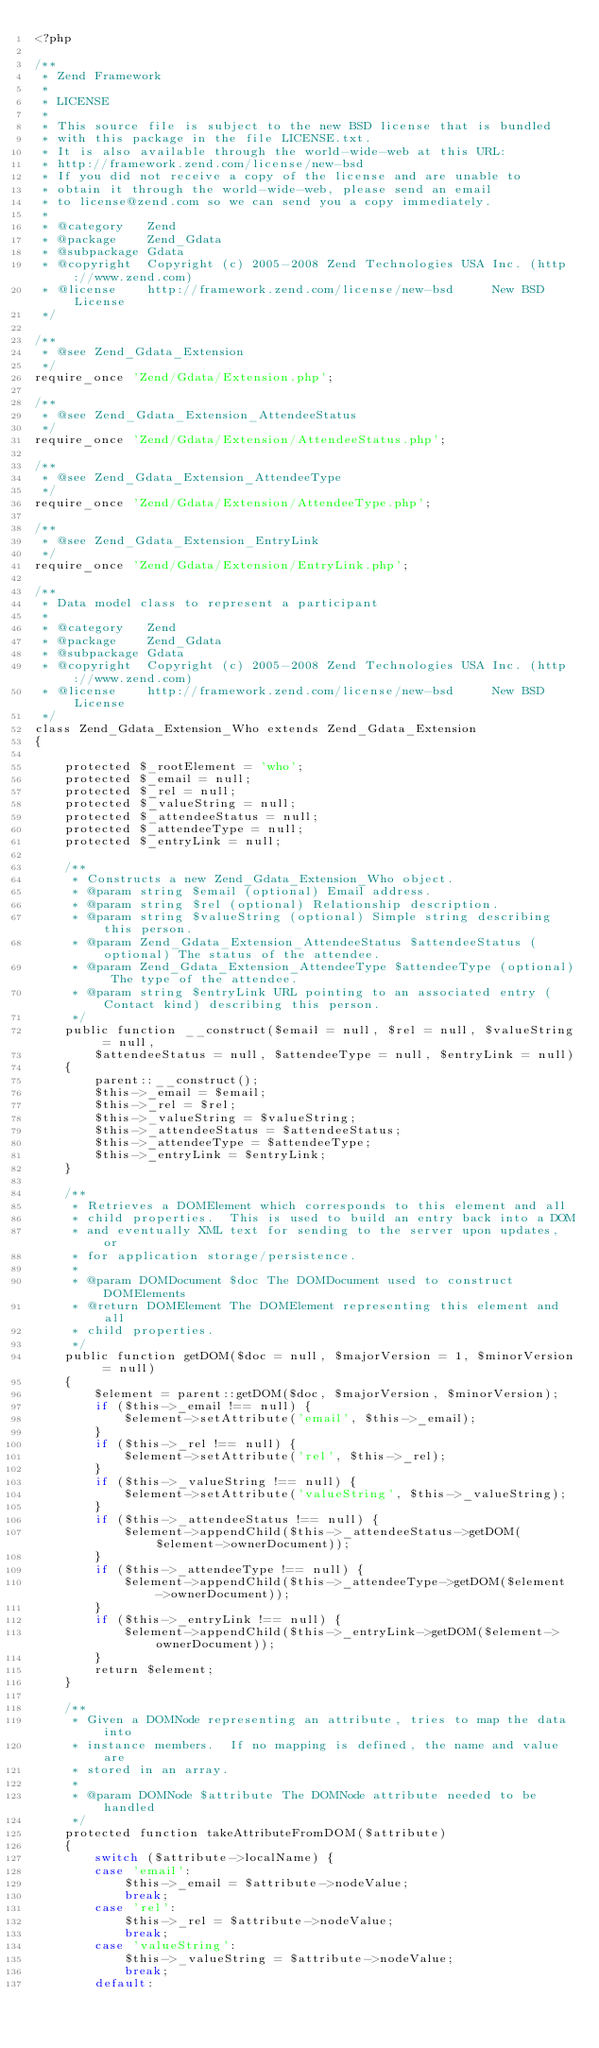Convert code to text. <code><loc_0><loc_0><loc_500><loc_500><_PHP_><?php

/**
 * Zend Framework
 *
 * LICENSE
 *
 * This source file is subject to the new BSD license that is bundled
 * with this package in the file LICENSE.txt.
 * It is also available through the world-wide-web at this URL:
 * http://framework.zend.com/license/new-bsd
 * If you did not receive a copy of the license and are unable to
 * obtain it through the world-wide-web, please send an email
 * to license@zend.com so we can send you a copy immediately.
 *
 * @category   Zend
 * @package    Zend_Gdata
 * @subpackage Gdata
 * @copyright  Copyright (c) 2005-2008 Zend Technologies USA Inc. (http://www.zend.com)
 * @license    http://framework.zend.com/license/new-bsd     New BSD License
 */

/**
 * @see Zend_Gdata_Extension
 */
require_once 'Zend/Gdata/Extension.php';

/**
 * @see Zend_Gdata_Extension_AttendeeStatus
 */
require_once 'Zend/Gdata/Extension/AttendeeStatus.php';

/**
 * @see Zend_Gdata_Extension_AttendeeType
 */
require_once 'Zend/Gdata/Extension/AttendeeType.php';

/**
 * @see Zend_Gdata_Extension_EntryLink
 */
require_once 'Zend/Gdata/Extension/EntryLink.php';

/**
 * Data model class to represent a participant
 *
 * @category   Zend
 * @package    Zend_Gdata
 * @subpackage Gdata
 * @copyright  Copyright (c) 2005-2008 Zend Technologies USA Inc. (http://www.zend.com)
 * @license    http://framework.zend.com/license/new-bsd     New BSD License
 */
class Zend_Gdata_Extension_Who extends Zend_Gdata_Extension
{

    protected $_rootElement = 'who';
    protected $_email = null;
    protected $_rel = null;
    protected $_valueString = null;
    protected $_attendeeStatus = null;
    protected $_attendeeType = null;
    protected $_entryLink = null;

    /**
     * Constructs a new Zend_Gdata_Extension_Who object.
     * @param string $email (optional) Email address.
     * @param string $rel (optional) Relationship description.
     * @param string $valueString (optional) Simple string describing this person.
     * @param Zend_Gdata_Extension_AttendeeStatus $attendeeStatus (optional) The status of the attendee.
     * @param Zend_Gdata_Extension_AttendeeType $attendeeType (optional) The type of the attendee.
     * @param string $entryLink URL pointing to an associated entry (Contact kind) describing this person.
     */
    public function __construct($email = null, $rel = null, $valueString = null,
        $attendeeStatus = null, $attendeeType = null, $entryLink = null)
    {
        parent::__construct();
        $this->_email = $email;
        $this->_rel = $rel;
        $this->_valueString = $valueString;
        $this->_attendeeStatus = $attendeeStatus;
        $this->_attendeeType = $attendeeType;
        $this->_entryLink = $entryLink;
    }

    /**
     * Retrieves a DOMElement which corresponds to this element and all
     * child properties.  This is used to build an entry back into a DOM
     * and eventually XML text for sending to the server upon updates, or
     * for application storage/persistence.
     *
     * @param DOMDocument $doc The DOMDocument used to construct DOMElements
     * @return DOMElement The DOMElement representing this element and all
     * child properties.
     */
    public function getDOM($doc = null, $majorVersion = 1, $minorVersion = null)
    {
        $element = parent::getDOM($doc, $majorVersion, $minorVersion);
        if ($this->_email !== null) {
            $element->setAttribute('email', $this->_email);
        }
        if ($this->_rel !== null) {
            $element->setAttribute('rel', $this->_rel);
        }
        if ($this->_valueString !== null) {
            $element->setAttribute('valueString', $this->_valueString);
        }
        if ($this->_attendeeStatus !== null) {
            $element->appendChild($this->_attendeeStatus->getDOM($element->ownerDocument));
        }
        if ($this->_attendeeType !== null) {
            $element->appendChild($this->_attendeeType->getDOM($element->ownerDocument));
        }
        if ($this->_entryLink !== null) {
            $element->appendChild($this->_entryLink->getDOM($element->ownerDocument));
        }
        return $element;
    }

    /**
     * Given a DOMNode representing an attribute, tries to map the data into
     * instance members.  If no mapping is defined, the name and value are
     * stored in an array.
     *
     * @param DOMNode $attribute The DOMNode attribute needed to be handled
     */
    protected function takeAttributeFromDOM($attribute)
    {
        switch ($attribute->localName) {
        case 'email':
            $this->_email = $attribute->nodeValue;
            break;
        case 'rel':
            $this->_rel = $attribute->nodeValue;
            break;
        case 'valueString':
            $this->_valueString = $attribute->nodeValue;
            break;
        default:</code> 